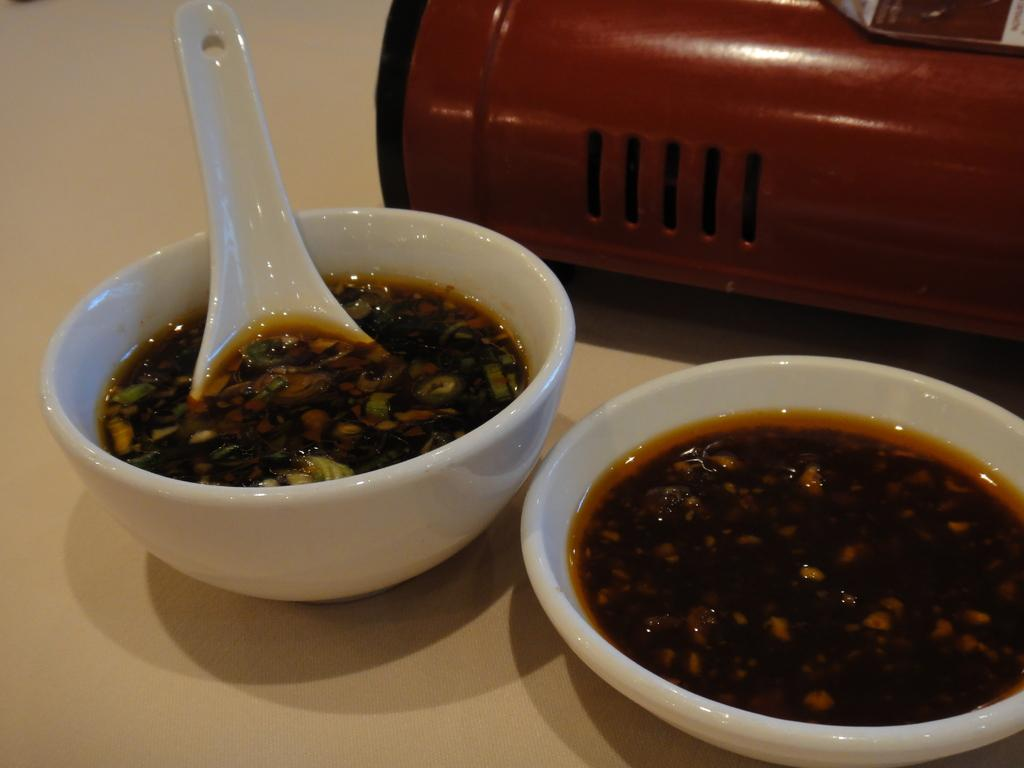What objects are on the table in the image? There are cups on the table. What color are some of the objects on the table? There are red color objects on the table. What is inside the cups on the table? Soap is present in the cups. Can you describe the contents of the right cup? There is soup in the right cup, and there is a spoon in it. What crime is being committed in the image? There is no crime being committed in the image; it shows cups with soap and soup. Who is the friend in the image? There is no friend present in the image; it only shows cups, soap, soup, and a spoon. 